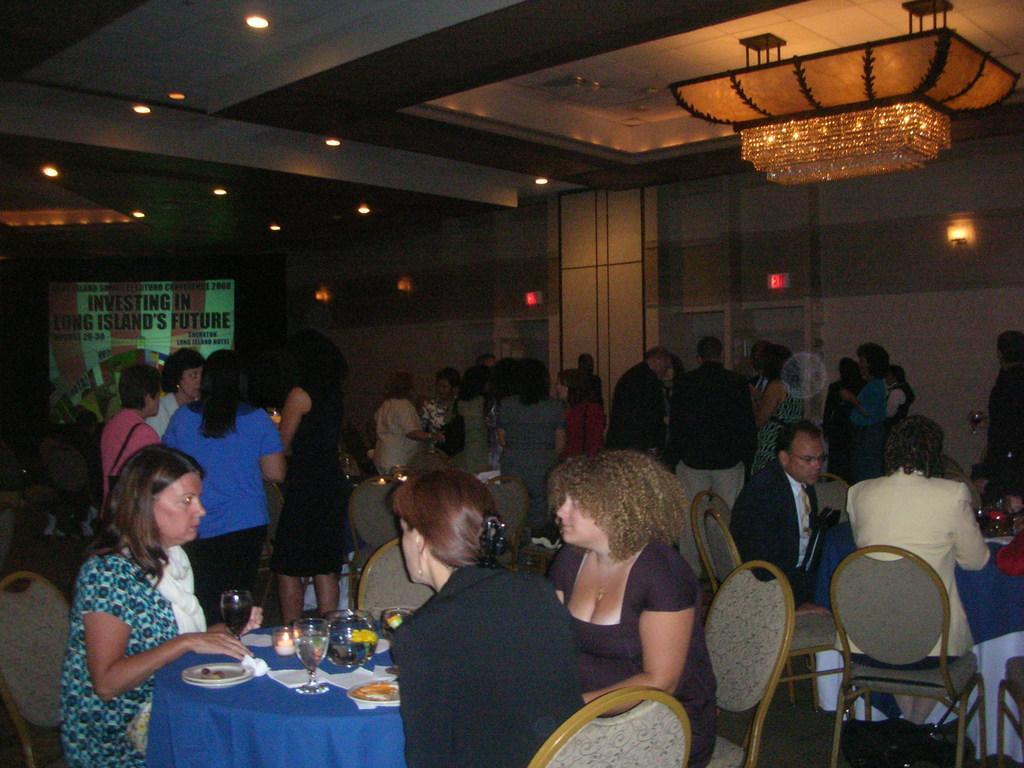Can you describe this image briefly? There are group of people standing and sitting on the chairs. This is a table which is covered with a blue cloth. These are wine glasses,plates and some papers which are placed on the table. it is ceiling light which is changed through the ceiling. At background I can see a banner,and these are the ceiling lights which are attached to the ceiling. 